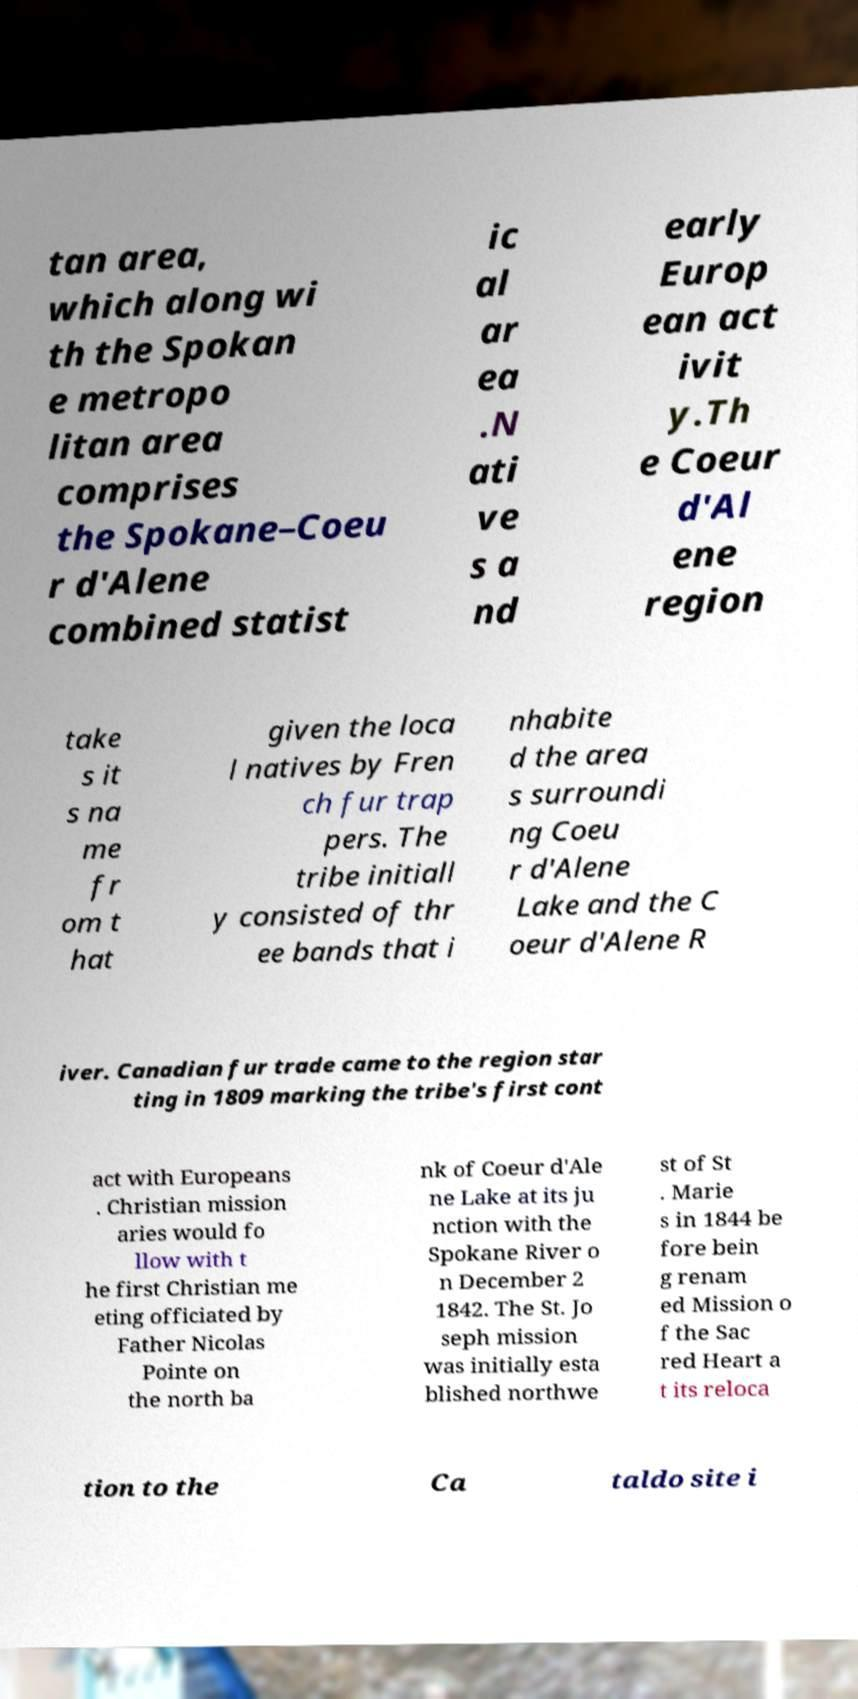For documentation purposes, I need the text within this image transcribed. Could you provide that? tan area, which along wi th the Spokan e metropo litan area comprises the Spokane–Coeu r d'Alene combined statist ic al ar ea .N ati ve s a nd early Europ ean act ivit y.Th e Coeur d'Al ene region take s it s na me fr om t hat given the loca l natives by Fren ch fur trap pers. The tribe initiall y consisted of thr ee bands that i nhabite d the area s surroundi ng Coeu r d'Alene Lake and the C oeur d'Alene R iver. Canadian fur trade came to the region star ting in 1809 marking the tribe's first cont act with Europeans . Christian mission aries would fo llow with t he first Christian me eting officiated by Father Nicolas Pointe on the north ba nk of Coeur d'Ale ne Lake at its ju nction with the Spokane River o n December 2 1842. The St. Jo seph mission was initially esta blished northwe st of St . Marie s in 1844 be fore bein g renam ed Mission o f the Sac red Heart a t its reloca tion to the Ca taldo site i 